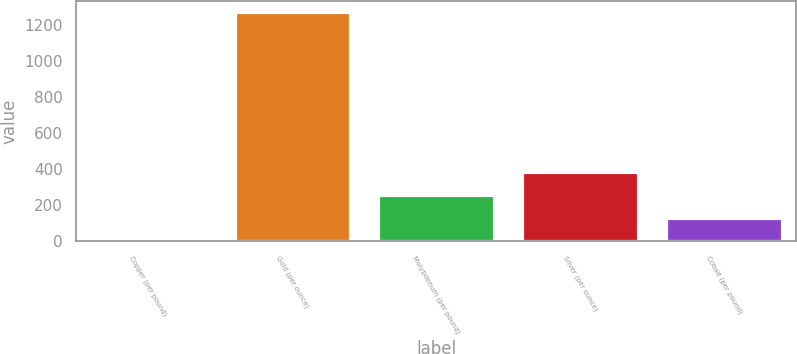<chart> <loc_0><loc_0><loc_500><loc_500><bar_chart><fcel>Copper (per pound)<fcel>Gold (per ounce)<fcel>Molybdenum (per pound)<fcel>Silver (per ounce)<fcel>Cobalt (per pound)<nl><fcel>3.59<fcel>1271<fcel>257.07<fcel>383.81<fcel>130.33<nl></chart> 